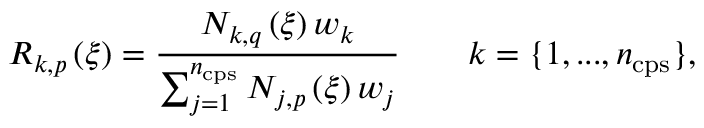<formula> <loc_0><loc_0><loc_500><loc_500>R _ { k , p } \left ( \xi \right ) = \frac { N _ { k , q } \left ( \xi \right ) w _ { k } } { \sum _ { j = 1 } ^ { n _ { c p s } } N _ { j , p } \left ( \xi \right ) w _ { j } } \quad k = \{ 1 , \dots , n _ { c p s } \} ,</formula> 